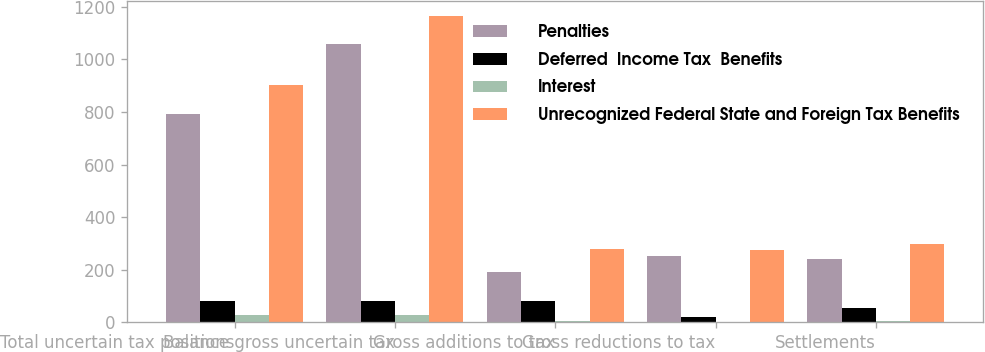Convert chart. <chart><loc_0><loc_0><loc_500><loc_500><stacked_bar_chart><ecel><fcel>Total uncertain tax positions<fcel>Balance gross uncertain tax<fcel>Gross additions to tax<fcel>Gross reductions to tax<fcel>Settlements<nl><fcel>Penalties<fcel>794<fcel>1058<fcel>193<fcel>253<fcel>240<nl><fcel>Deferred  Income Tax  Benefits<fcel>81<fcel>81<fcel>79<fcel>20<fcel>54<nl><fcel>Interest<fcel>27<fcel>27<fcel>6<fcel>1<fcel>3<nl><fcel>Unrecognized Federal State and Foreign Tax Benefits<fcel>902<fcel>1166<fcel>278<fcel>274<fcel>297<nl></chart> 